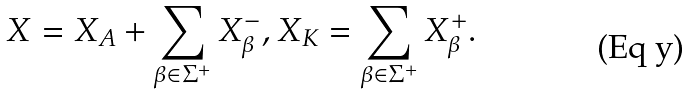<formula> <loc_0><loc_0><loc_500><loc_500>X = X _ { A } + \sum _ { \beta \in \Sigma ^ { + } } X _ { \beta } ^ { - } , X _ { K } = \sum _ { \beta \in \Sigma ^ { + } } X _ { \beta } ^ { + } .</formula> 